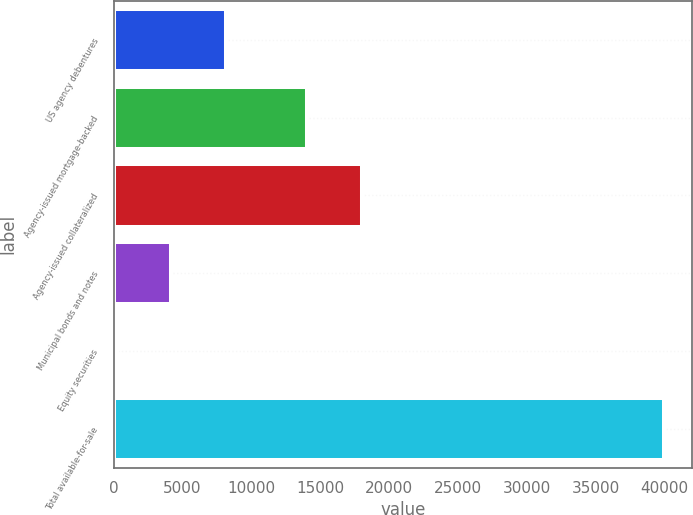Convert chart. <chart><loc_0><loc_0><loc_500><loc_500><bar_chart><fcel>US agency debentures<fcel>Agency-issued mortgage-backed<fcel>Agency-issued collateralized<fcel>Municipal bonds and notes<fcel>Equity securities<fcel>Total available-for-sale<nl><fcel>8176.8<fcel>14050<fcel>18028.9<fcel>4197.9<fcel>219<fcel>40008<nl></chart> 